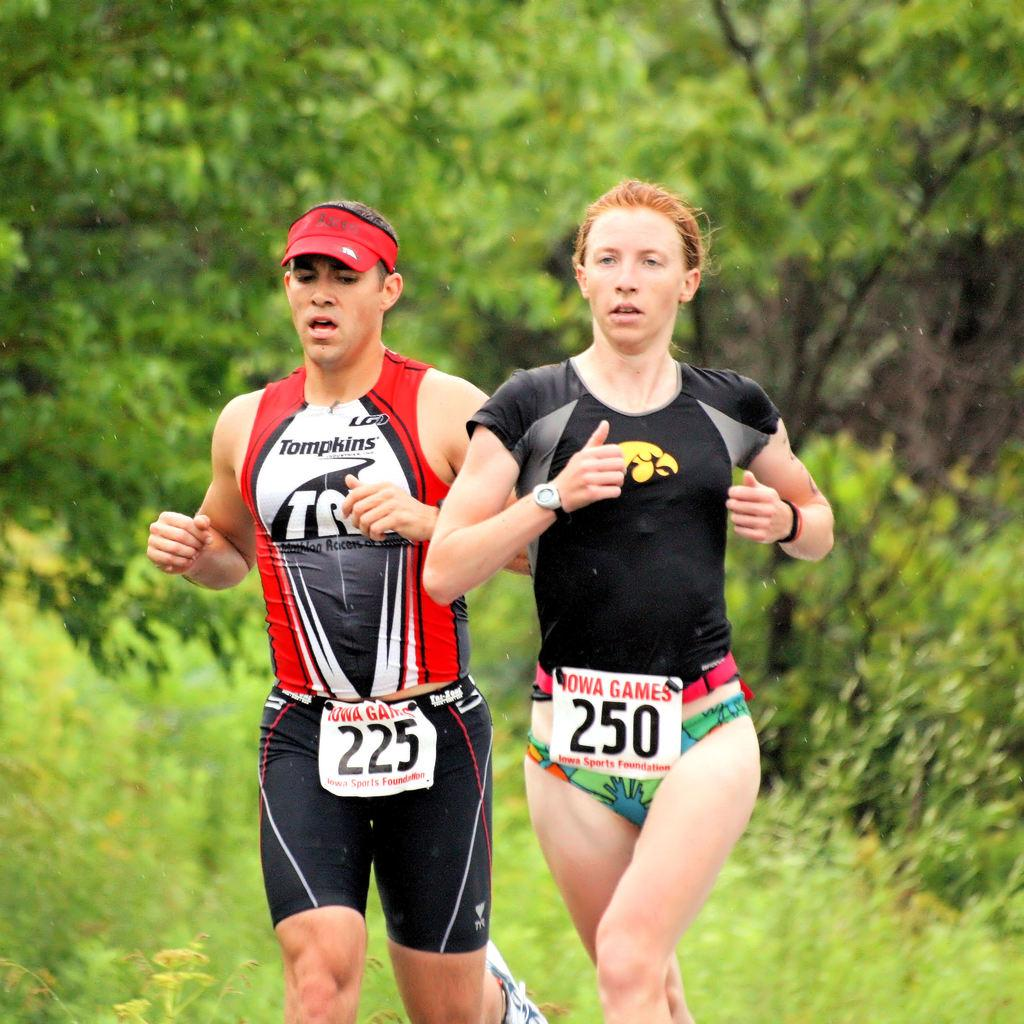<image>
Relay a brief, clear account of the picture shown. A woman runs in a race with the participant bib number 250. 